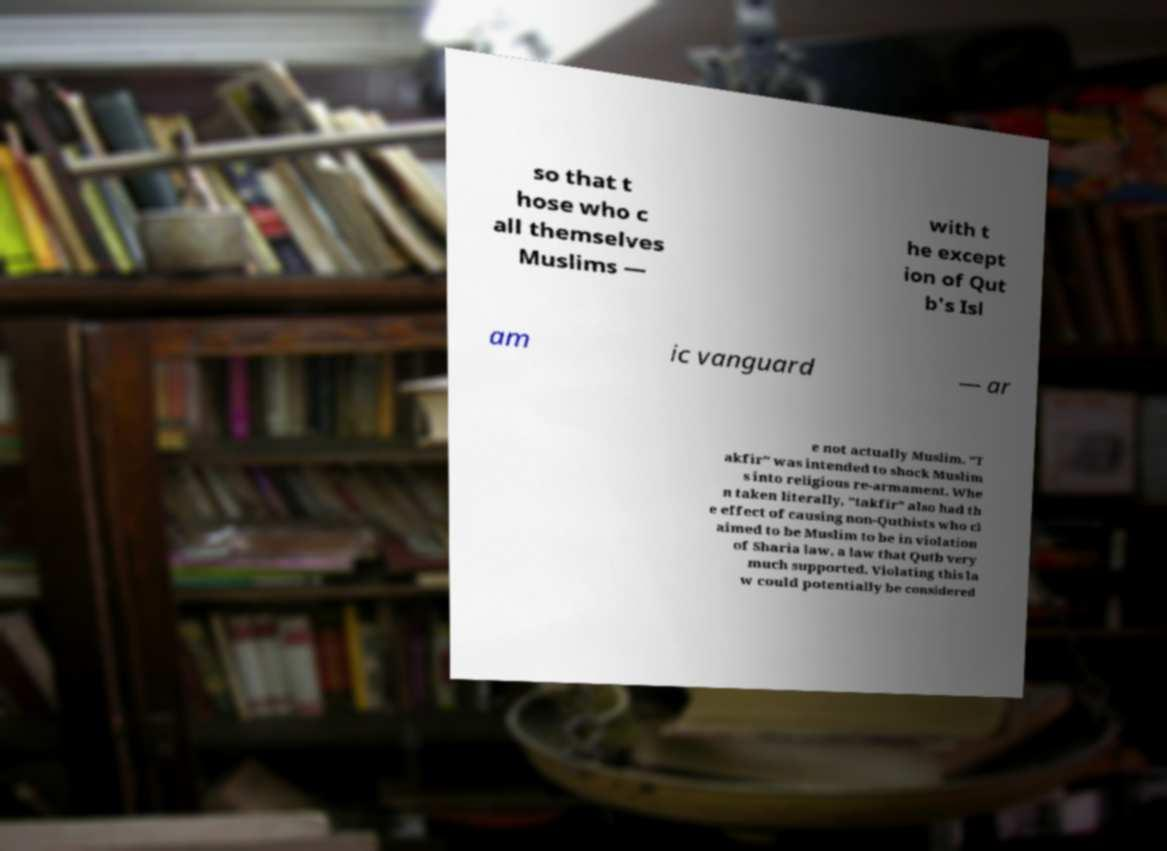Could you assist in decoding the text presented in this image and type it out clearly? so that t hose who c all themselves Muslims — with t he except ion of Qut b's Isl am ic vanguard — ar e not actually Muslim. "T akfir" was intended to shock Muslim s into religious re-armament. Whe n taken literally, "takfir" also had th e effect of causing non-Qutbists who cl aimed to be Muslim to be in violation of Sharia law, a law that Qutb very much supported. Violating this la w could potentially be considered 